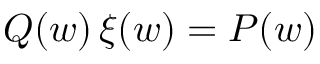<formula> <loc_0><loc_0><loc_500><loc_500>Q ( w ) \, \xi ( w ) = P ( w )</formula> 